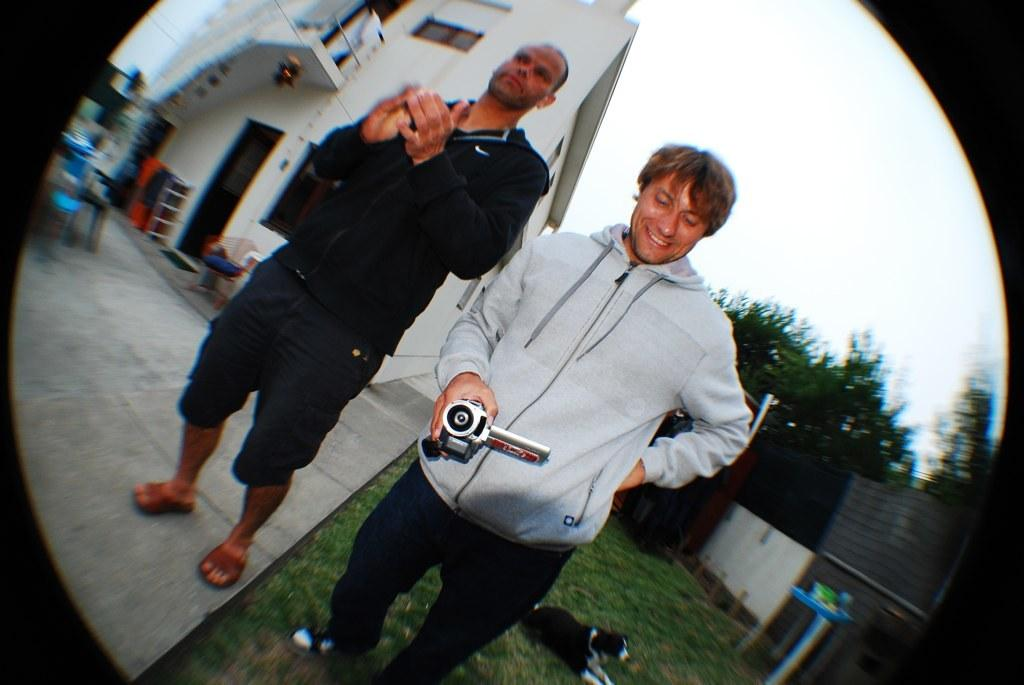How many people are in the image? There are two people standing in the image. What is the man holding in the image? The man is holding a camera. What is the dog doing in the image? The dog is on the grass in the image. What can be seen in the background of the image? There is a building, a wall, trees, and the sky visible in the background of the image. Where is the basin located in the image? There is no basin present in the image. What type of animal is sitting on the wall in the image? There is no animal sitting on the wall in the image; only a dog is present on the grass. 